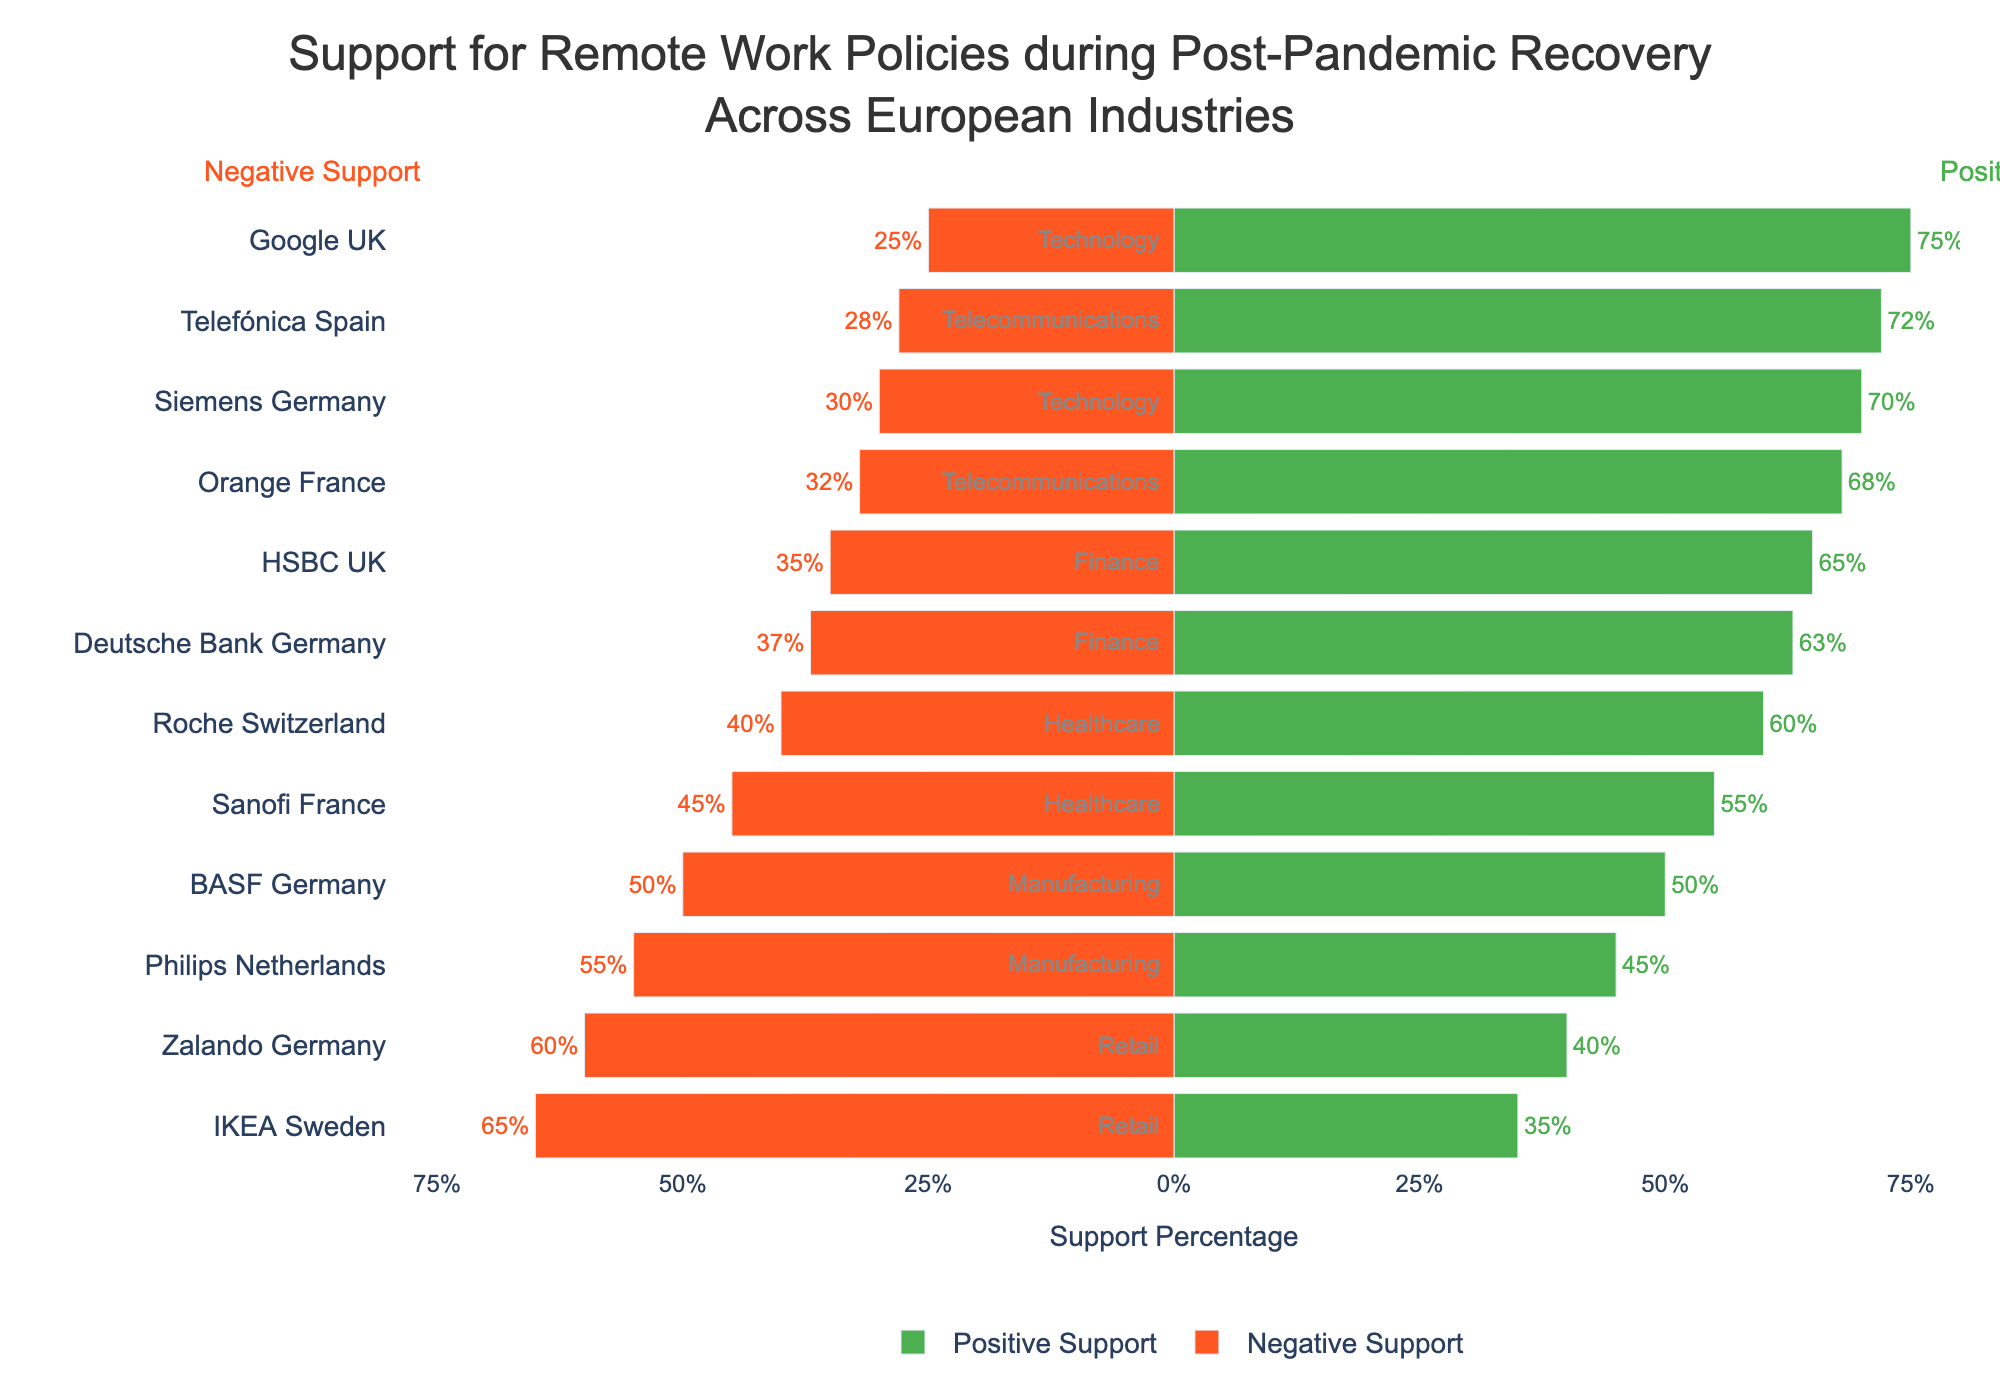Which industry has the highest combined positive support percentage, and what is that percentage? Combine the positive support percentages for all entities within each industry, and then compare the total support percentages to identify the highest one. The technology sector has Google UK (75%) and Siemens Germany (70%), combining for 145%.
Answer: Technology, 145% Which entity has the largest discrepancy between positive and negative support, and what is that discrepancy percentage? Calculate the difference between positive and negative support for each entity. The largest difference is for Google UK with a positive support of 75% and a negative support of 25%, resulting in a 50% discrepancy.
Answer: Google UK, 50% How does the positive support percentage for Telefónica Spain compare to Philips Netherlands? Compare Telefónica Spain's positive support percentage (72%) with Philips Netherlands' positive support percentage (45%). Telefónica Spain has a higher positive support by 27%.
Answer: Telefónica Spain has 27% more positive support Which industry has the lowest combined negative support percentage, and what is that percentage? Combine the negative support percentages for all entities within each industry and compare to identify the lowest one. The telecommunications sector, with Orange France (32%) and Telefónica Spain (28%), combines for a 60% negative support percentage.
Answer: Telecommunications, 60% What is the average positive support percentage across all industries? Sum the positive support percentages for all entities and divide by the number of entities (12). Total positive support is 698%. The average is 698% / 12 = 58.167%.
Answer: 58.167% Which entity, Sanofi France or HSBC UK, has a higher negative support percentage, and by how much? Compare Sanofi France's negative support percentage (45%) to HSBC UK's (35%). Sanofi France has a higher negative support by 10%.
Answer: Sanofi France by 10% What is the range of the negative support percentages across the listed entities? Identify the highest and lowest negative support percentages. The highest is IKEA Sweden with 65%, and the lowest is Telefónica Spain with 28%. The range is 65% - 28% = 37%.
Answer: 37% How many industries have at least one entity with a negative support percentage of 50% or more? Check each industry to see if any of their entities have a negative support percentage of 50% or more. Manufacturing (Philips Netherlands) and Retail (Zalando Germany and IKEA Sweden) both qualify.
Answer: 2 industries Which industry shows the closest balance between positive and negative support, and which entity within that industry is most balanced? Find the entity with the smallest difference between positive and negative support within each industry. Manufacturing industry has BASF Germany with 50% positive and 50% negative, showing a perfect balance.
Answer: Manufacturing, BASF Germany 